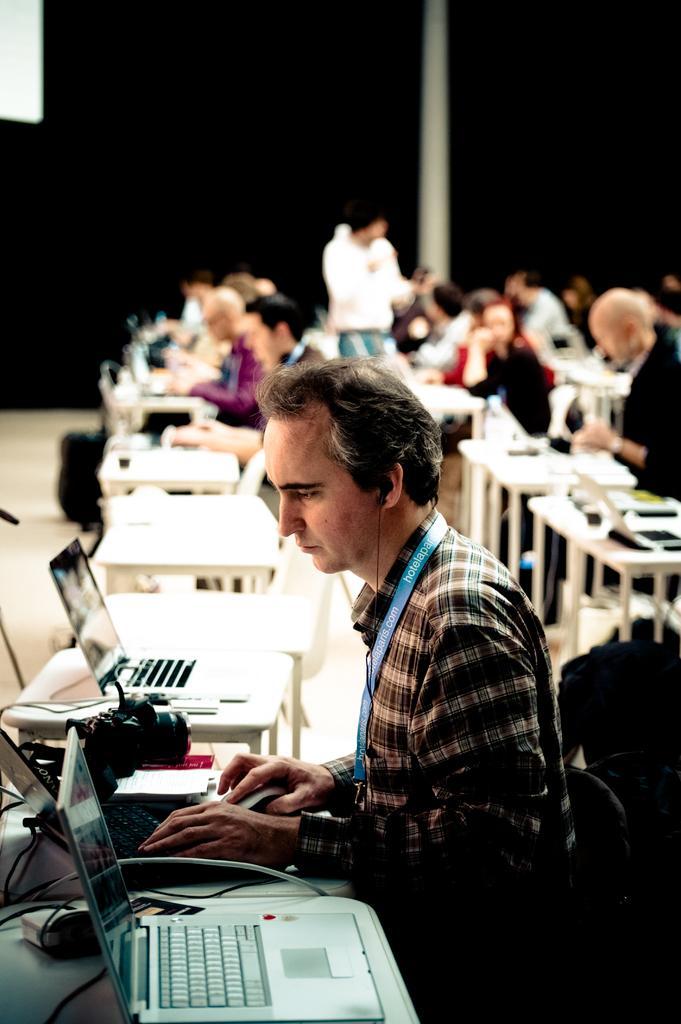Please provide a concise description of this image. In this image, we can see persons sitting in front of tables. There are laptops in the bottom left of the image. In the background, image is blurred. 